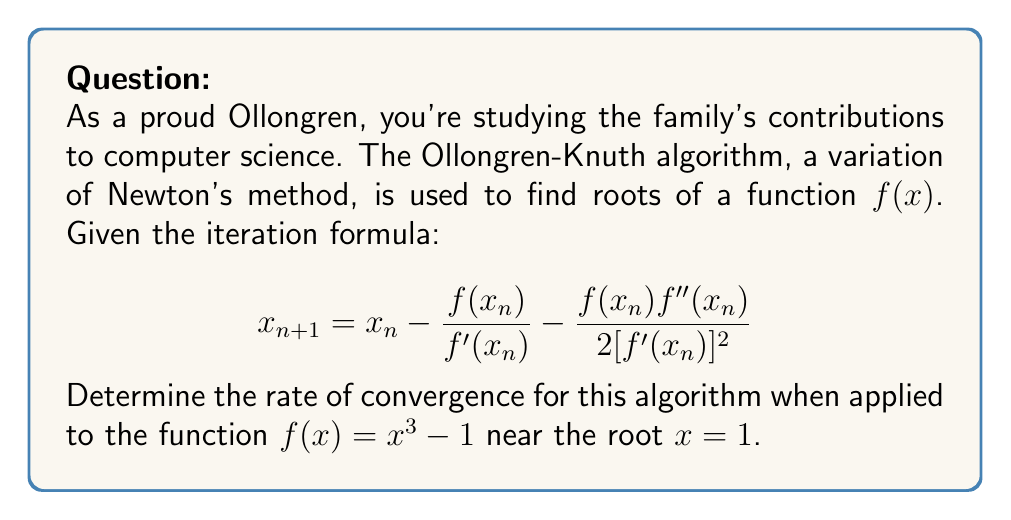What is the answer to this math problem? To determine the rate of convergence, we need to analyze the error term in each iteration. Let's follow these steps:

1) First, we need to calculate $f'(x)$ and $f''(x)$:
   $f'(x) = 3x^2$
   $f''(x) = 6x$

2) Now, let's define the error at step n as $e_n = x_n - \alpha$, where $\alpha$ is the true root (in this case, $\alpha = 1$).

3) We can expand $f(x_n)$, $f'(x_n)$, and $f''(x_n)$ using Taylor series around $x = \alpha$:

   $f(x_n) = f(\alpha + e_n) = f(\alpha) + f'(\alpha)e_n + \frac{1}{2}f''(\alpha)e_n^2 + \frac{1}{6}f'''(\alpha)e_n^3 + O(e_n^4)$

   $f'(x_n) = f'(\alpha) + f''(\alpha)e_n + \frac{1}{2}f'''(\alpha)e_n^2 + O(e_n^3)$

   $f''(x_n) = f''(\alpha) + f'''(\alpha)e_n + O(e_n^2)$

4) Substituting these into the iteration formula and simplifying (this is a lengthy process), we get:

   $e_{n+1} = -\frac{1}{6}\frac{f'''(\alpha)}{[f'(\alpha)]^2}e_n^3 + O(e_n^4)$

5) For our specific function $f(x) = x^3 - 1$:
   $f'(1) = 3$
   $f''(1) = 6$
   $f'''(1) = 6$

6) Substituting these values:

   $e_{n+1} = -\frac{1}{6}\frac{6}{9}e_n^3 + O(e_n^4) = -\frac{1}{9}e_n^3 + O(e_n^4)$

7) The dominant term in this error equation is $e_n^3$, which indicates cubic convergence.
Answer: Cubic convergence 